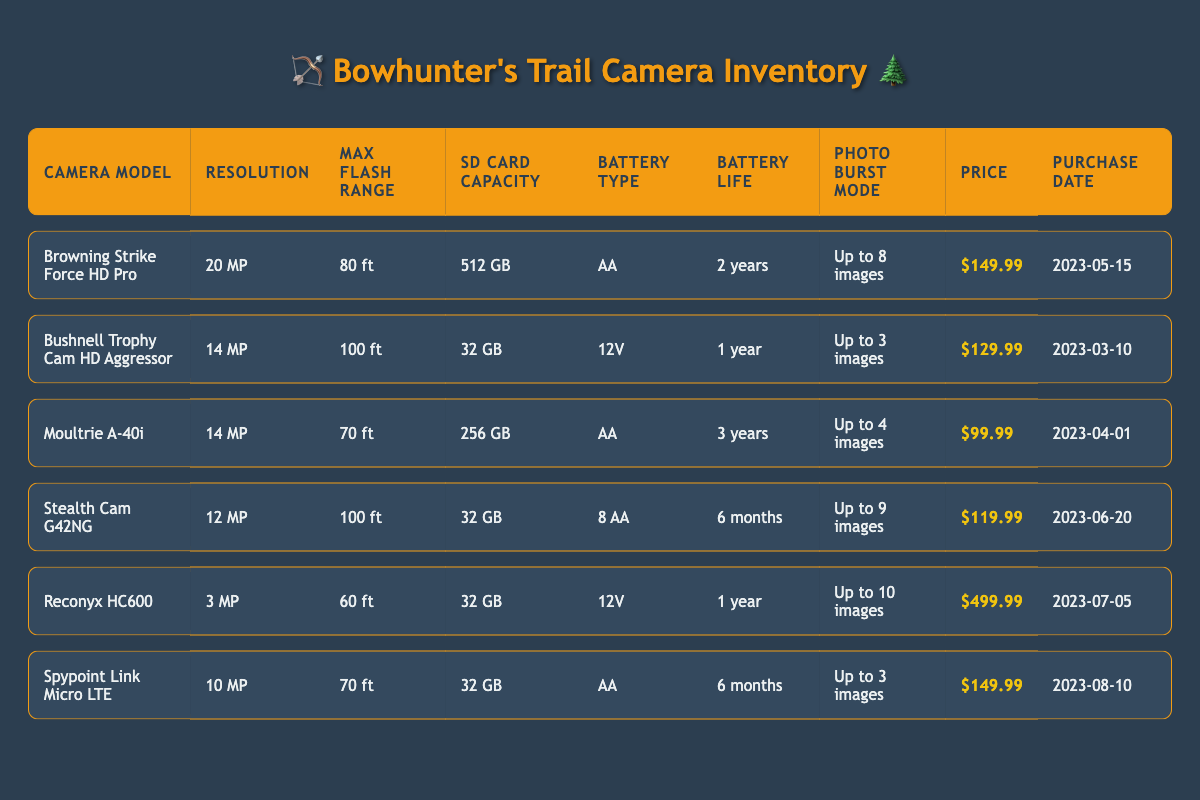What is the resolution of the Browning Strike Force HD Pro? The table directly lists the resolution for each camera model. For the Browning Strike Force HD Pro, the resolution is mentioned as "20 MP."
Answer: 20 MP Which camera has the longest battery life? To find the camera with the longest battery life, we look at the "Battery Life" column. The Moultrie A-40i has a battery life of "3 years," which is longer than the others listed.
Answer: Moultrie A-40i How many cameras have a resolution greater than 10 MP? We can filter through the "Resolution" column to count how many cameras exceed 10 MP. The Browning Strike Force HD Pro (20 MP) and Bushnell Trophy Cam HD Aggressor (14 MP) are the only models with resolutions greater than 10 MP. Thus, there are 2 cameras.
Answer: 2 Is the price of the Reconyx HC600 greater than $400? Evaluating the "Price" column for the Reconyx HC600, it is listed as "$499.99," which is indeed greater than $400.
Answer: Yes What is the average price of the cameras listed in the inventory? We need to sum the prices of all cameras: 149.99 + 129.99 + 99.99 + 119.99 + 499.99 + 149.99 = 1,149.94. Then, dividing by the total number of cameras (6) gives us an average price of 1,149.94 / 6 ≈ 191.66.
Answer: 191.66 Which camera has a max flash range of 100 ft? Looking through the "Max Flash Range" column, we find that the Bushnell Trophy Cam HD Aggressor and Stealth Cam G42NG both have a max flash range of 100 ft.
Answer: Bushnell Trophy Cam HD Aggressor, Stealth Cam G42NG How many cameras use AA batteries? The "Battery Type" column reveals that the Browning Strike Force HD Pro, Moultrie A-40i, and Spypoint Link Micro LTE all utilize AA batteries. Thus, there are 3 cameras that use AA batteries.
Answer: 3 What is the difference in SD Card Capacity between the camera with the highest and lowest capacity? The highest SD Card Capacity is 512 GB (Browning Strike Force HD Pro) and the lowest is 32 GB (found in multiple models). The difference is calculated as 512 GB - 32 GB = 480 GB.
Answer: 480 GB Is it true that the most recent purchase date is for the Spypoint Link Micro LTE? Checking the "Purchase Date" column, the Spypoint Link Micro LTE has a purchase date of "2023-08-10," which is indeed the latest date compared to the others.
Answer: Yes 